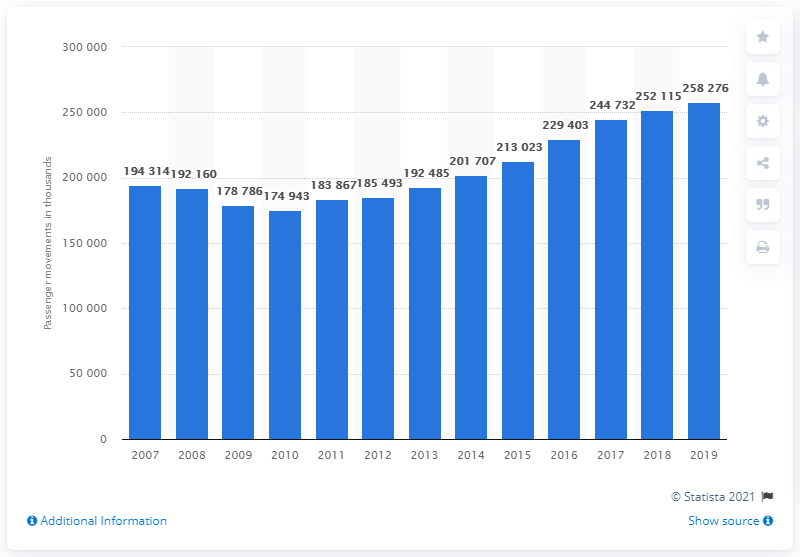Mention a couple of crucial points in this snapshot. Passenger movements began to decrease in the year 2010. 